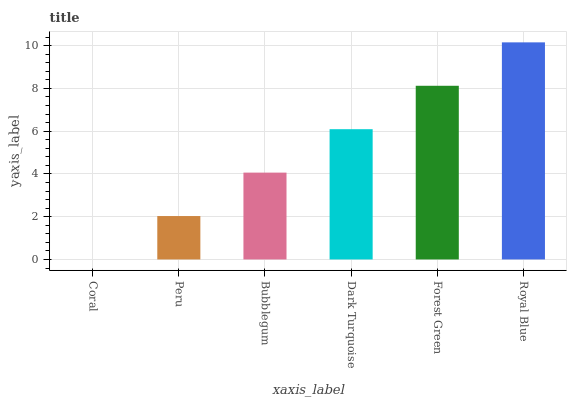Is Coral the minimum?
Answer yes or no. Yes. Is Royal Blue the maximum?
Answer yes or no. Yes. Is Peru the minimum?
Answer yes or no. No. Is Peru the maximum?
Answer yes or no. No. Is Peru greater than Coral?
Answer yes or no. Yes. Is Coral less than Peru?
Answer yes or no. Yes. Is Coral greater than Peru?
Answer yes or no. No. Is Peru less than Coral?
Answer yes or no. No. Is Dark Turquoise the high median?
Answer yes or no. Yes. Is Bubblegum the low median?
Answer yes or no. Yes. Is Coral the high median?
Answer yes or no. No. Is Dark Turquoise the low median?
Answer yes or no. No. 